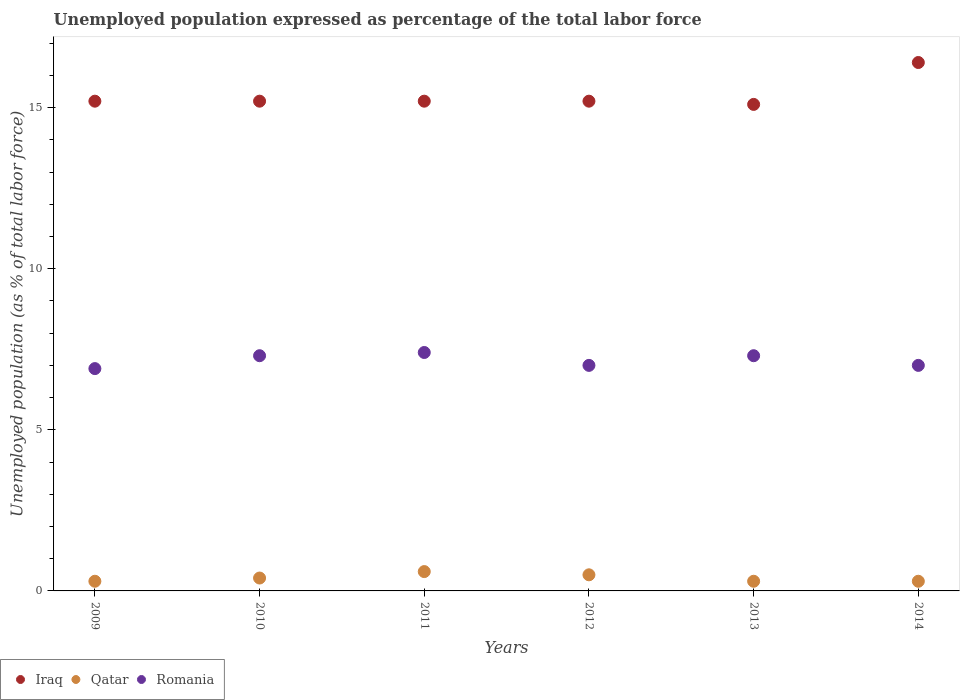Across all years, what is the maximum unemployment in in Iraq?
Your answer should be compact. 16.4. Across all years, what is the minimum unemployment in in Qatar?
Make the answer very short. 0.3. In which year was the unemployment in in Romania maximum?
Your answer should be compact. 2011. In which year was the unemployment in in Romania minimum?
Your answer should be compact. 2009. What is the total unemployment in in Romania in the graph?
Give a very brief answer. 42.9. What is the difference between the unemployment in in Romania in 2009 and that in 2014?
Your response must be concise. -0.1. What is the difference between the unemployment in in Qatar in 2010 and the unemployment in in Iraq in 2012?
Ensure brevity in your answer.  -14.8. What is the average unemployment in in Romania per year?
Give a very brief answer. 7.15. In the year 2009, what is the difference between the unemployment in in Qatar and unemployment in in Iraq?
Offer a terse response. -14.9. In how many years, is the unemployment in in Iraq greater than 7 %?
Your answer should be very brief. 6. What is the ratio of the unemployment in in Iraq in 2011 to that in 2014?
Your answer should be compact. 0.93. Is the unemployment in in Iraq in 2009 less than that in 2014?
Your answer should be compact. Yes. What is the difference between the highest and the second highest unemployment in in Romania?
Your response must be concise. 0.1. In how many years, is the unemployment in in Qatar greater than the average unemployment in in Qatar taken over all years?
Your answer should be very brief. 2. Is the sum of the unemployment in in Romania in 2010 and 2014 greater than the maximum unemployment in in Iraq across all years?
Provide a short and direct response. No. Does the unemployment in in Qatar monotonically increase over the years?
Provide a succinct answer. No. Is the unemployment in in Iraq strictly less than the unemployment in in Romania over the years?
Ensure brevity in your answer.  No. How many dotlines are there?
Make the answer very short. 3. How many years are there in the graph?
Keep it short and to the point. 6. What is the difference between two consecutive major ticks on the Y-axis?
Keep it short and to the point. 5. Are the values on the major ticks of Y-axis written in scientific E-notation?
Ensure brevity in your answer.  No. How are the legend labels stacked?
Your answer should be very brief. Horizontal. What is the title of the graph?
Your answer should be very brief. Unemployed population expressed as percentage of the total labor force. Does "Equatorial Guinea" appear as one of the legend labels in the graph?
Provide a short and direct response. No. What is the label or title of the Y-axis?
Ensure brevity in your answer.  Unemployed population (as % of total labor force). What is the Unemployed population (as % of total labor force) of Iraq in 2009?
Make the answer very short. 15.2. What is the Unemployed population (as % of total labor force) in Qatar in 2009?
Keep it short and to the point. 0.3. What is the Unemployed population (as % of total labor force) of Romania in 2009?
Your response must be concise. 6.9. What is the Unemployed population (as % of total labor force) in Iraq in 2010?
Keep it short and to the point. 15.2. What is the Unemployed population (as % of total labor force) of Qatar in 2010?
Your answer should be compact. 0.4. What is the Unemployed population (as % of total labor force) in Romania in 2010?
Provide a short and direct response. 7.3. What is the Unemployed population (as % of total labor force) of Iraq in 2011?
Your answer should be very brief. 15.2. What is the Unemployed population (as % of total labor force) of Qatar in 2011?
Provide a succinct answer. 0.6. What is the Unemployed population (as % of total labor force) in Romania in 2011?
Offer a very short reply. 7.4. What is the Unemployed population (as % of total labor force) of Iraq in 2012?
Your answer should be compact. 15.2. What is the Unemployed population (as % of total labor force) in Qatar in 2012?
Your answer should be compact. 0.5. What is the Unemployed population (as % of total labor force) of Romania in 2012?
Offer a terse response. 7. What is the Unemployed population (as % of total labor force) in Iraq in 2013?
Offer a terse response. 15.1. What is the Unemployed population (as % of total labor force) of Qatar in 2013?
Provide a short and direct response. 0.3. What is the Unemployed population (as % of total labor force) of Romania in 2013?
Offer a very short reply. 7.3. What is the Unemployed population (as % of total labor force) in Iraq in 2014?
Keep it short and to the point. 16.4. What is the Unemployed population (as % of total labor force) in Qatar in 2014?
Your answer should be very brief. 0.3. Across all years, what is the maximum Unemployed population (as % of total labor force) of Iraq?
Offer a very short reply. 16.4. Across all years, what is the maximum Unemployed population (as % of total labor force) in Qatar?
Your answer should be very brief. 0.6. Across all years, what is the maximum Unemployed population (as % of total labor force) of Romania?
Offer a terse response. 7.4. Across all years, what is the minimum Unemployed population (as % of total labor force) of Iraq?
Make the answer very short. 15.1. Across all years, what is the minimum Unemployed population (as % of total labor force) in Qatar?
Offer a terse response. 0.3. Across all years, what is the minimum Unemployed population (as % of total labor force) of Romania?
Your answer should be compact. 6.9. What is the total Unemployed population (as % of total labor force) in Iraq in the graph?
Make the answer very short. 92.3. What is the total Unemployed population (as % of total labor force) of Romania in the graph?
Offer a terse response. 42.9. What is the difference between the Unemployed population (as % of total labor force) of Iraq in 2009 and that in 2010?
Give a very brief answer. 0. What is the difference between the Unemployed population (as % of total labor force) in Iraq in 2009 and that in 2011?
Provide a succinct answer. 0. What is the difference between the Unemployed population (as % of total labor force) of Romania in 2009 and that in 2011?
Offer a very short reply. -0.5. What is the difference between the Unemployed population (as % of total labor force) of Romania in 2009 and that in 2013?
Make the answer very short. -0.4. What is the difference between the Unemployed population (as % of total labor force) in Iraq in 2009 and that in 2014?
Ensure brevity in your answer.  -1.2. What is the difference between the Unemployed population (as % of total labor force) in Romania in 2009 and that in 2014?
Offer a very short reply. -0.1. What is the difference between the Unemployed population (as % of total labor force) of Iraq in 2010 and that in 2011?
Your answer should be compact. 0. What is the difference between the Unemployed population (as % of total labor force) in Qatar in 2010 and that in 2011?
Offer a very short reply. -0.2. What is the difference between the Unemployed population (as % of total labor force) in Romania in 2010 and that in 2011?
Offer a terse response. -0.1. What is the difference between the Unemployed population (as % of total labor force) of Iraq in 2010 and that in 2012?
Your answer should be compact. 0. What is the difference between the Unemployed population (as % of total labor force) in Romania in 2010 and that in 2012?
Offer a very short reply. 0.3. What is the difference between the Unemployed population (as % of total labor force) in Qatar in 2010 and that in 2014?
Offer a very short reply. 0.1. What is the difference between the Unemployed population (as % of total labor force) in Iraq in 2011 and that in 2012?
Offer a terse response. 0. What is the difference between the Unemployed population (as % of total labor force) in Romania in 2011 and that in 2012?
Provide a short and direct response. 0.4. What is the difference between the Unemployed population (as % of total labor force) in Qatar in 2011 and that in 2013?
Provide a short and direct response. 0.3. What is the difference between the Unemployed population (as % of total labor force) of Romania in 2011 and that in 2013?
Your response must be concise. 0.1. What is the difference between the Unemployed population (as % of total labor force) of Iraq in 2011 and that in 2014?
Offer a terse response. -1.2. What is the difference between the Unemployed population (as % of total labor force) in Qatar in 2011 and that in 2014?
Ensure brevity in your answer.  0.3. What is the difference between the Unemployed population (as % of total labor force) of Romania in 2011 and that in 2014?
Give a very brief answer. 0.4. What is the difference between the Unemployed population (as % of total labor force) in Iraq in 2012 and that in 2013?
Provide a short and direct response. 0.1. What is the difference between the Unemployed population (as % of total labor force) in Qatar in 2012 and that in 2013?
Keep it short and to the point. 0.2. What is the difference between the Unemployed population (as % of total labor force) in Romania in 2012 and that in 2013?
Offer a terse response. -0.3. What is the difference between the Unemployed population (as % of total labor force) in Romania in 2013 and that in 2014?
Keep it short and to the point. 0.3. What is the difference between the Unemployed population (as % of total labor force) in Iraq in 2009 and the Unemployed population (as % of total labor force) in Qatar in 2010?
Ensure brevity in your answer.  14.8. What is the difference between the Unemployed population (as % of total labor force) of Qatar in 2009 and the Unemployed population (as % of total labor force) of Romania in 2010?
Make the answer very short. -7. What is the difference between the Unemployed population (as % of total labor force) of Iraq in 2009 and the Unemployed population (as % of total labor force) of Qatar in 2011?
Keep it short and to the point. 14.6. What is the difference between the Unemployed population (as % of total labor force) of Iraq in 2009 and the Unemployed population (as % of total labor force) of Romania in 2012?
Provide a succinct answer. 8.2. What is the difference between the Unemployed population (as % of total labor force) of Qatar in 2009 and the Unemployed population (as % of total labor force) of Romania in 2012?
Provide a succinct answer. -6.7. What is the difference between the Unemployed population (as % of total labor force) of Qatar in 2009 and the Unemployed population (as % of total labor force) of Romania in 2013?
Give a very brief answer. -7. What is the difference between the Unemployed population (as % of total labor force) of Qatar in 2009 and the Unemployed population (as % of total labor force) of Romania in 2014?
Your response must be concise. -6.7. What is the difference between the Unemployed population (as % of total labor force) in Iraq in 2010 and the Unemployed population (as % of total labor force) in Qatar in 2011?
Give a very brief answer. 14.6. What is the difference between the Unemployed population (as % of total labor force) of Qatar in 2010 and the Unemployed population (as % of total labor force) of Romania in 2011?
Give a very brief answer. -7. What is the difference between the Unemployed population (as % of total labor force) of Iraq in 2010 and the Unemployed population (as % of total labor force) of Qatar in 2013?
Provide a succinct answer. 14.9. What is the difference between the Unemployed population (as % of total labor force) in Iraq in 2010 and the Unemployed population (as % of total labor force) in Romania in 2013?
Make the answer very short. 7.9. What is the difference between the Unemployed population (as % of total labor force) of Qatar in 2010 and the Unemployed population (as % of total labor force) of Romania in 2014?
Your response must be concise. -6.6. What is the difference between the Unemployed population (as % of total labor force) in Iraq in 2011 and the Unemployed population (as % of total labor force) in Qatar in 2012?
Keep it short and to the point. 14.7. What is the difference between the Unemployed population (as % of total labor force) of Iraq in 2011 and the Unemployed population (as % of total labor force) of Romania in 2012?
Your answer should be compact. 8.2. What is the difference between the Unemployed population (as % of total labor force) of Qatar in 2011 and the Unemployed population (as % of total labor force) of Romania in 2012?
Offer a very short reply. -6.4. What is the difference between the Unemployed population (as % of total labor force) of Iraq in 2011 and the Unemployed population (as % of total labor force) of Romania in 2013?
Provide a succinct answer. 7.9. What is the difference between the Unemployed population (as % of total labor force) of Qatar in 2011 and the Unemployed population (as % of total labor force) of Romania in 2013?
Ensure brevity in your answer.  -6.7. What is the difference between the Unemployed population (as % of total labor force) in Iraq in 2012 and the Unemployed population (as % of total labor force) in Romania in 2013?
Your answer should be compact. 7.9. What is the difference between the Unemployed population (as % of total labor force) in Qatar in 2012 and the Unemployed population (as % of total labor force) in Romania in 2013?
Make the answer very short. -6.8. What is the difference between the Unemployed population (as % of total labor force) in Iraq in 2013 and the Unemployed population (as % of total labor force) in Romania in 2014?
Keep it short and to the point. 8.1. What is the average Unemployed population (as % of total labor force) of Iraq per year?
Your answer should be very brief. 15.38. What is the average Unemployed population (as % of total labor force) of Qatar per year?
Your response must be concise. 0.4. What is the average Unemployed population (as % of total labor force) in Romania per year?
Offer a terse response. 7.15. In the year 2009, what is the difference between the Unemployed population (as % of total labor force) of Iraq and Unemployed population (as % of total labor force) of Qatar?
Offer a terse response. 14.9. In the year 2009, what is the difference between the Unemployed population (as % of total labor force) of Iraq and Unemployed population (as % of total labor force) of Romania?
Provide a succinct answer. 8.3. In the year 2010, what is the difference between the Unemployed population (as % of total labor force) in Iraq and Unemployed population (as % of total labor force) in Romania?
Your answer should be very brief. 7.9. In the year 2010, what is the difference between the Unemployed population (as % of total labor force) of Qatar and Unemployed population (as % of total labor force) of Romania?
Give a very brief answer. -6.9. In the year 2011, what is the difference between the Unemployed population (as % of total labor force) of Iraq and Unemployed population (as % of total labor force) of Qatar?
Your answer should be compact. 14.6. In the year 2012, what is the difference between the Unemployed population (as % of total labor force) of Iraq and Unemployed population (as % of total labor force) of Romania?
Offer a terse response. 8.2. In the year 2013, what is the difference between the Unemployed population (as % of total labor force) in Iraq and Unemployed population (as % of total labor force) in Qatar?
Keep it short and to the point. 14.8. In the year 2013, what is the difference between the Unemployed population (as % of total labor force) in Iraq and Unemployed population (as % of total labor force) in Romania?
Offer a very short reply. 7.8. In the year 2014, what is the difference between the Unemployed population (as % of total labor force) of Iraq and Unemployed population (as % of total labor force) of Qatar?
Give a very brief answer. 16.1. In the year 2014, what is the difference between the Unemployed population (as % of total labor force) of Iraq and Unemployed population (as % of total labor force) of Romania?
Offer a very short reply. 9.4. What is the ratio of the Unemployed population (as % of total labor force) in Iraq in 2009 to that in 2010?
Offer a very short reply. 1. What is the ratio of the Unemployed population (as % of total labor force) in Qatar in 2009 to that in 2010?
Give a very brief answer. 0.75. What is the ratio of the Unemployed population (as % of total labor force) of Romania in 2009 to that in 2010?
Your answer should be very brief. 0.95. What is the ratio of the Unemployed population (as % of total labor force) of Iraq in 2009 to that in 2011?
Offer a terse response. 1. What is the ratio of the Unemployed population (as % of total labor force) of Qatar in 2009 to that in 2011?
Make the answer very short. 0.5. What is the ratio of the Unemployed population (as % of total labor force) of Romania in 2009 to that in 2011?
Make the answer very short. 0.93. What is the ratio of the Unemployed population (as % of total labor force) in Iraq in 2009 to that in 2012?
Give a very brief answer. 1. What is the ratio of the Unemployed population (as % of total labor force) of Romania in 2009 to that in 2012?
Make the answer very short. 0.99. What is the ratio of the Unemployed population (as % of total labor force) of Iraq in 2009 to that in 2013?
Keep it short and to the point. 1.01. What is the ratio of the Unemployed population (as % of total labor force) of Romania in 2009 to that in 2013?
Provide a succinct answer. 0.95. What is the ratio of the Unemployed population (as % of total labor force) in Iraq in 2009 to that in 2014?
Your answer should be compact. 0.93. What is the ratio of the Unemployed population (as % of total labor force) in Romania in 2009 to that in 2014?
Your answer should be compact. 0.99. What is the ratio of the Unemployed population (as % of total labor force) of Iraq in 2010 to that in 2011?
Your answer should be compact. 1. What is the ratio of the Unemployed population (as % of total labor force) in Qatar in 2010 to that in 2011?
Provide a short and direct response. 0.67. What is the ratio of the Unemployed population (as % of total labor force) in Romania in 2010 to that in 2011?
Give a very brief answer. 0.99. What is the ratio of the Unemployed population (as % of total labor force) in Romania in 2010 to that in 2012?
Provide a succinct answer. 1.04. What is the ratio of the Unemployed population (as % of total labor force) of Iraq in 2010 to that in 2013?
Give a very brief answer. 1.01. What is the ratio of the Unemployed population (as % of total labor force) in Qatar in 2010 to that in 2013?
Make the answer very short. 1.33. What is the ratio of the Unemployed population (as % of total labor force) in Romania in 2010 to that in 2013?
Keep it short and to the point. 1. What is the ratio of the Unemployed population (as % of total labor force) in Iraq in 2010 to that in 2014?
Your answer should be very brief. 0.93. What is the ratio of the Unemployed population (as % of total labor force) of Romania in 2010 to that in 2014?
Your response must be concise. 1.04. What is the ratio of the Unemployed population (as % of total labor force) of Iraq in 2011 to that in 2012?
Your answer should be very brief. 1. What is the ratio of the Unemployed population (as % of total labor force) of Qatar in 2011 to that in 2012?
Provide a succinct answer. 1.2. What is the ratio of the Unemployed population (as % of total labor force) in Romania in 2011 to that in 2012?
Your response must be concise. 1.06. What is the ratio of the Unemployed population (as % of total labor force) of Iraq in 2011 to that in 2013?
Your answer should be compact. 1.01. What is the ratio of the Unemployed population (as % of total labor force) of Qatar in 2011 to that in 2013?
Give a very brief answer. 2. What is the ratio of the Unemployed population (as % of total labor force) in Romania in 2011 to that in 2013?
Your response must be concise. 1.01. What is the ratio of the Unemployed population (as % of total labor force) in Iraq in 2011 to that in 2014?
Keep it short and to the point. 0.93. What is the ratio of the Unemployed population (as % of total labor force) in Qatar in 2011 to that in 2014?
Offer a terse response. 2. What is the ratio of the Unemployed population (as % of total labor force) in Romania in 2011 to that in 2014?
Offer a terse response. 1.06. What is the ratio of the Unemployed population (as % of total labor force) in Iraq in 2012 to that in 2013?
Ensure brevity in your answer.  1.01. What is the ratio of the Unemployed population (as % of total labor force) of Qatar in 2012 to that in 2013?
Ensure brevity in your answer.  1.67. What is the ratio of the Unemployed population (as % of total labor force) of Romania in 2012 to that in 2013?
Make the answer very short. 0.96. What is the ratio of the Unemployed population (as % of total labor force) of Iraq in 2012 to that in 2014?
Provide a succinct answer. 0.93. What is the ratio of the Unemployed population (as % of total labor force) of Iraq in 2013 to that in 2014?
Provide a short and direct response. 0.92. What is the ratio of the Unemployed population (as % of total labor force) in Qatar in 2013 to that in 2014?
Provide a short and direct response. 1. What is the ratio of the Unemployed population (as % of total labor force) of Romania in 2013 to that in 2014?
Offer a terse response. 1.04. What is the difference between the highest and the second highest Unemployed population (as % of total labor force) of Iraq?
Your answer should be compact. 1.2. What is the difference between the highest and the second highest Unemployed population (as % of total labor force) in Qatar?
Keep it short and to the point. 0.1. What is the difference between the highest and the lowest Unemployed population (as % of total labor force) in Qatar?
Provide a short and direct response. 0.3. What is the difference between the highest and the lowest Unemployed population (as % of total labor force) of Romania?
Your response must be concise. 0.5. 